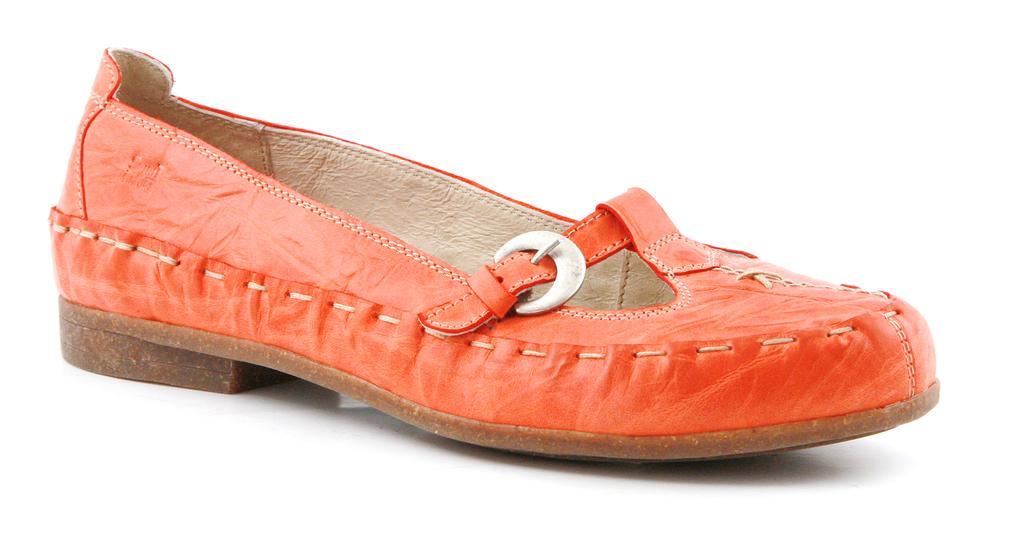Describe this image in one or two sentences. in this image we can see an orange color shoe on a surface. 